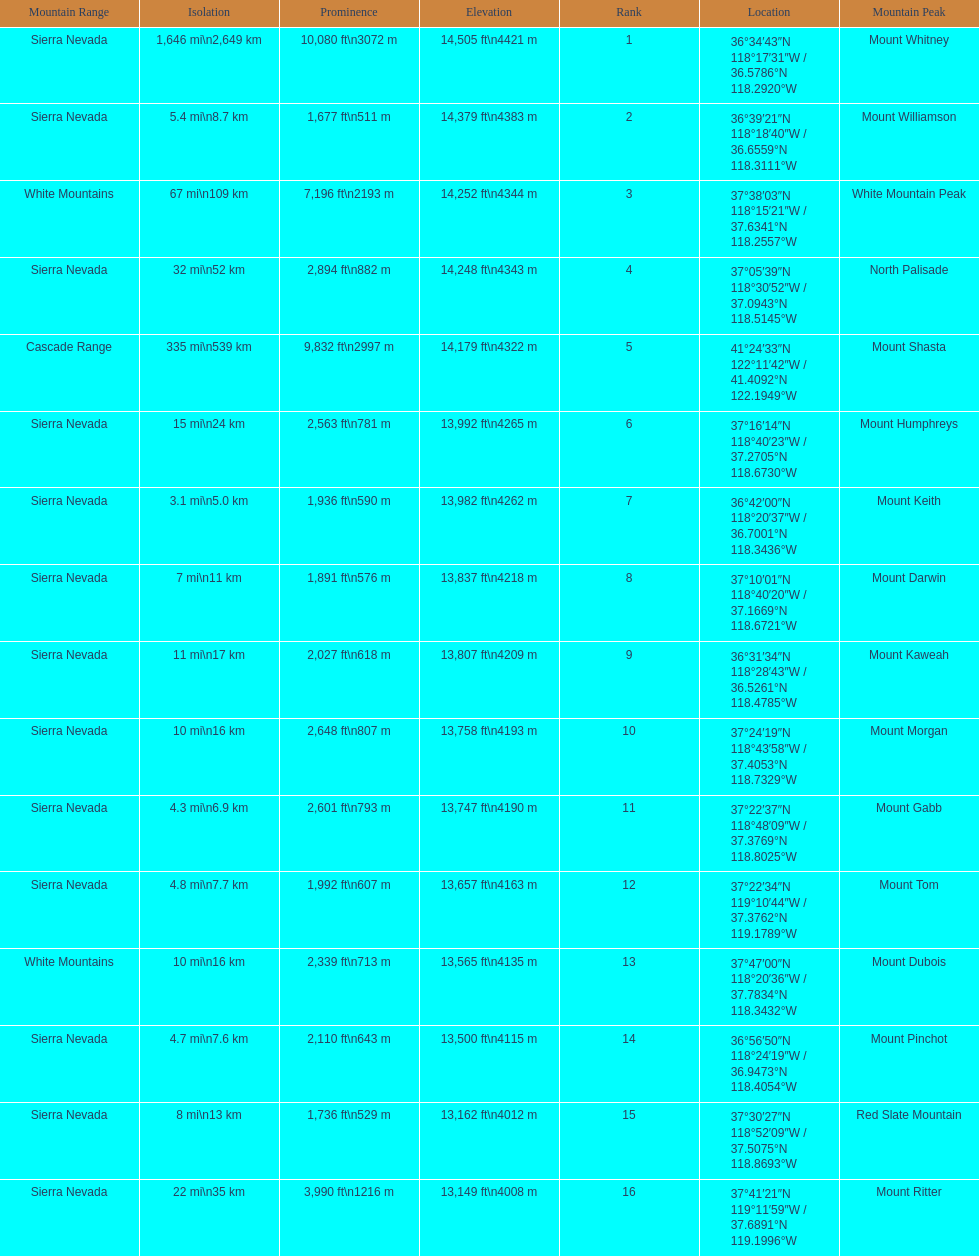Which mountain peaks are lower than 14,000 ft? Mount Humphreys, Mount Keith, Mount Darwin, Mount Kaweah, Mount Morgan, Mount Gabb, Mount Tom, Mount Dubois, Mount Pinchot, Red Slate Mountain, Mount Ritter. Are any of them below 13,500? if so, which ones? Red Slate Mountain, Mount Ritter. What's the lowest peak? 13,149 ft\n4008 m. Which one is that? Mount Ritter. 